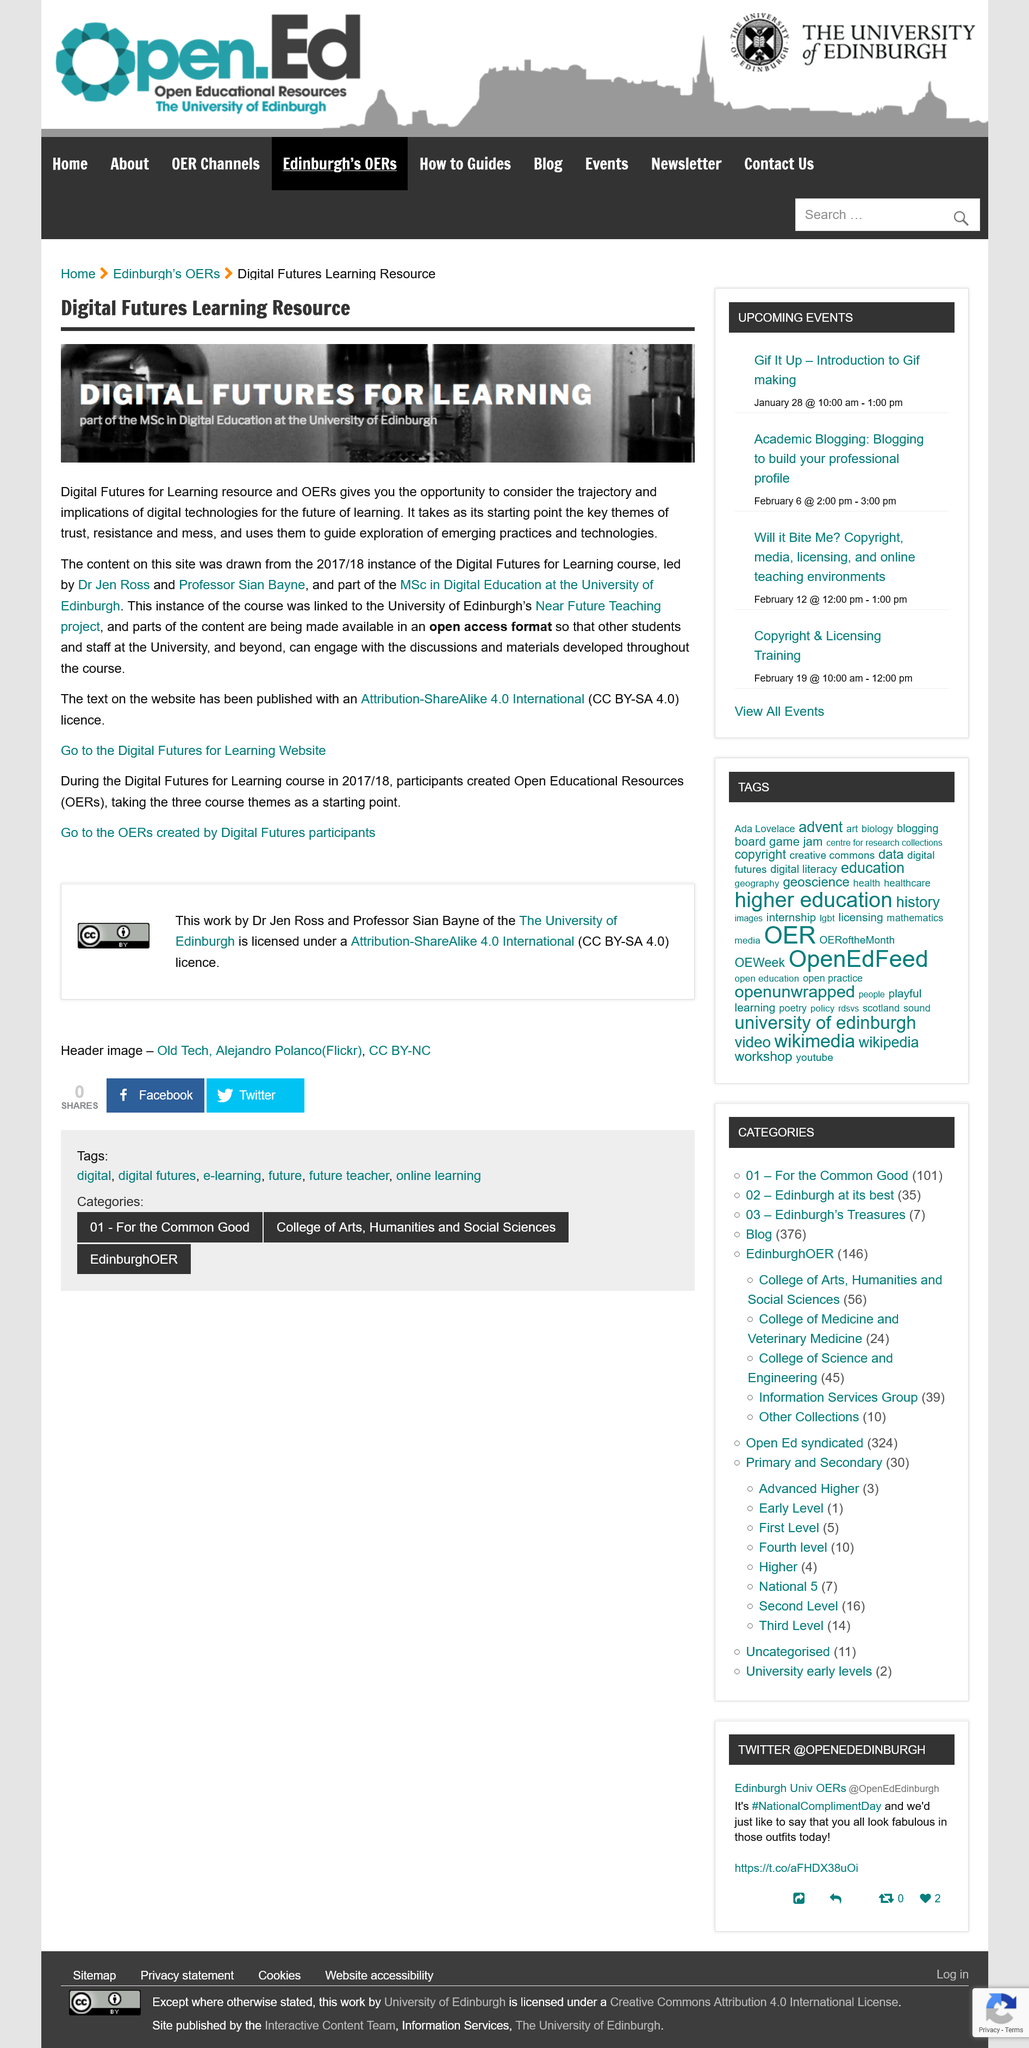Mention a couple of crucial points in this snapshot. Digital Futures for Learning is affiliated with the University of Edinburgh. Dr. Jen Ross and Professor Sian Bayne led the Digital Futures for Learning course in the 2017/18 academic year. Yes, Digital Futures for Learning has its own website. 